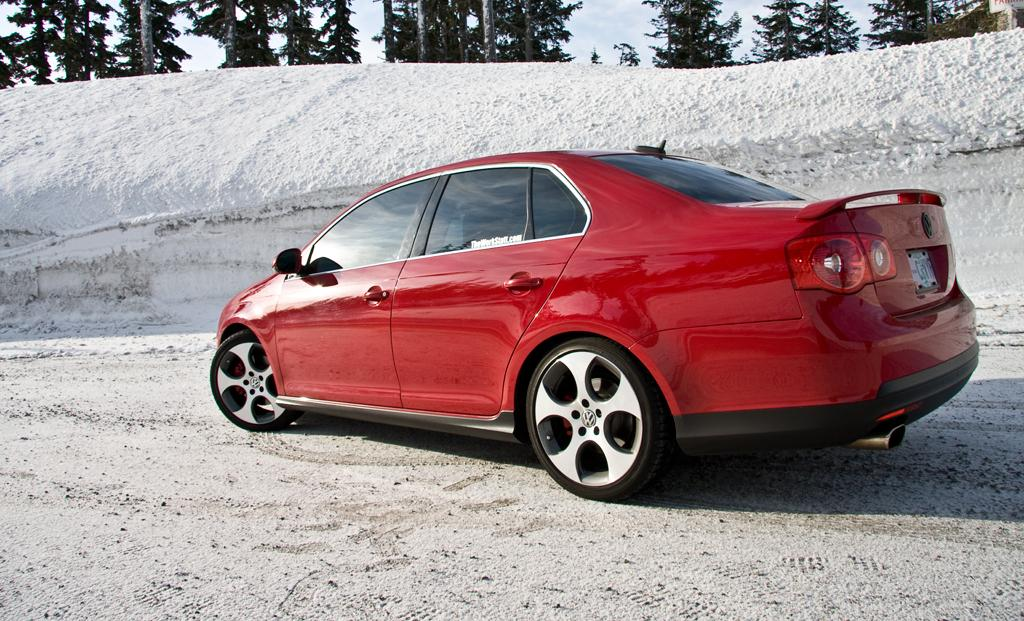What color is the car in the image? The car in the image is red. Where is the car located in the image? The car is on the road in the image. What can be seen in the background of the image? There is snow, trees, and the sky visible in the background of the image. How much salt is present in the image? There is no salt visible in the image. The image features a red car on the road with snow, trees, and the sky in the background. 